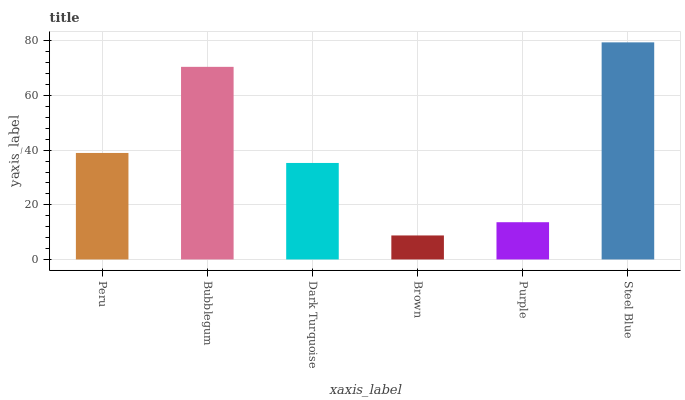Is Brown the minimum?
Answer yes or no. Yes. Is Steel Blue the maximum?
Answer yes or no. Yes. Is Bubblegum the minimum?
Answer yes or no. No. Is Bubblegum the maximum?
Answer yes or no. No. Is Bubblegum greater than Peru?
Answer yes or no. Yes. Is Peru less than Bubblegum?
Answer yes or no. Yes. Is Peru greater than Bubblegum?
Answer yes or no. No. Is Bubblegum less than Peru?
Answer yes or no. No. Is Peru the high median?
Answer yes or no. Yes. Is Dark Turquoise the low median?
Answer yes or no. Yes. Is Steel Blue the high median?
Answer yes or no. No. Is Brown the low median?
Answer yes or no. No. 